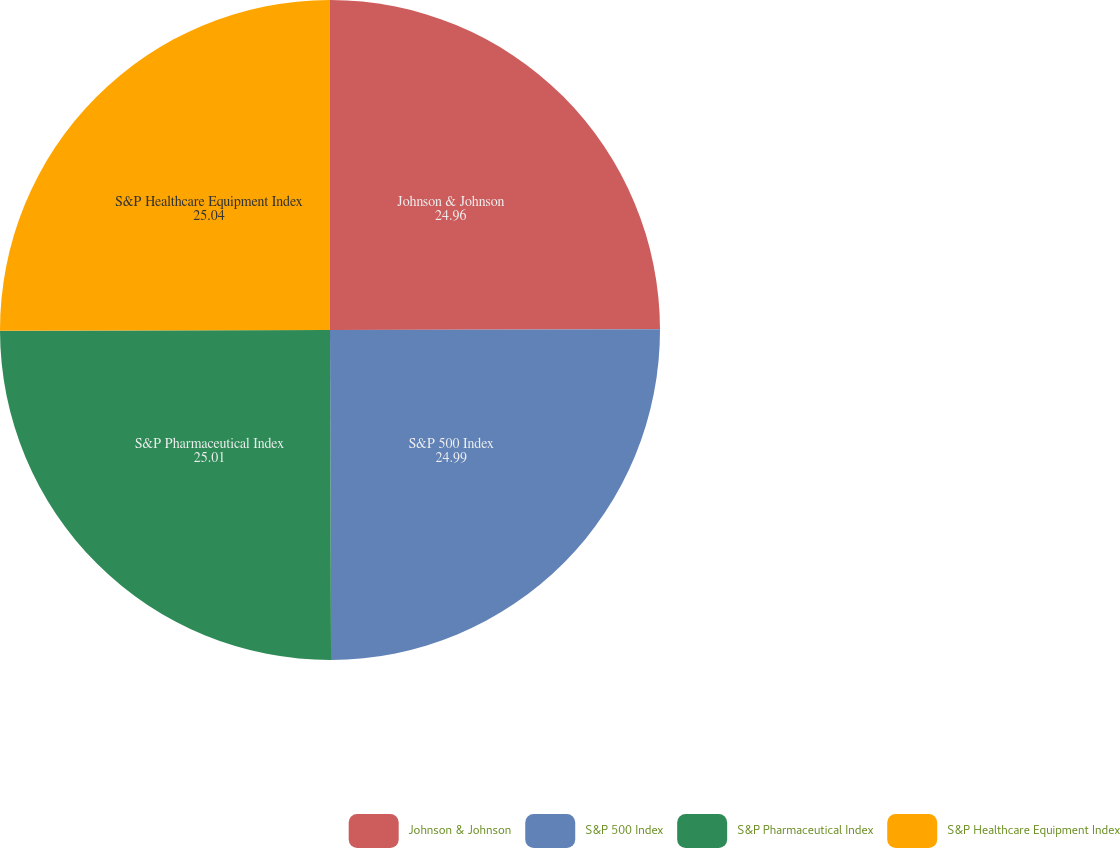Convert chart to OTSL. <chart><loc_0><loc_0><loc_500><loc_500><pie_chart><fcel>Johnson & Johnson<fcel>S&P 500 Index<fcel>S&P Pharmaceutical Index<fcel>S&P Healthcare Equipment Index<nl><fcel>24.96%<fcel>24.99%<fcel>25.01%<fcel>25.04%<nl></chart> 